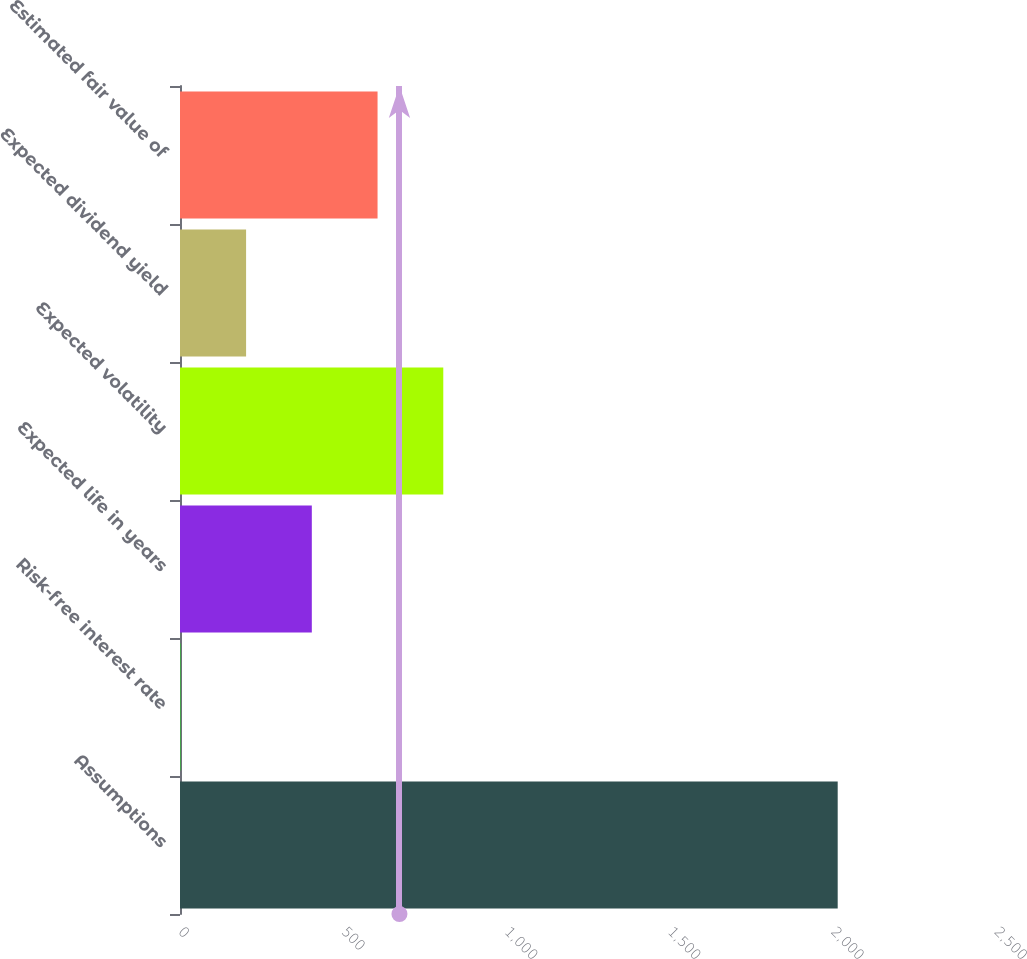Convert chart. <chart><loc_0><loc_0><loc_500><loc_500><bar_chart><fcel>Assumptions<fcel>Risk-free interest rate<fcel>Expected life in years<fcel>Expected volatility<fcel>Expected dividend yield<fcel>Estimated fair value of<nl><fcel>2015<fcel>1.08<fcel>403.86<fcel>806.64<fcel>202.47<fcel>605.25<nl></chart> 